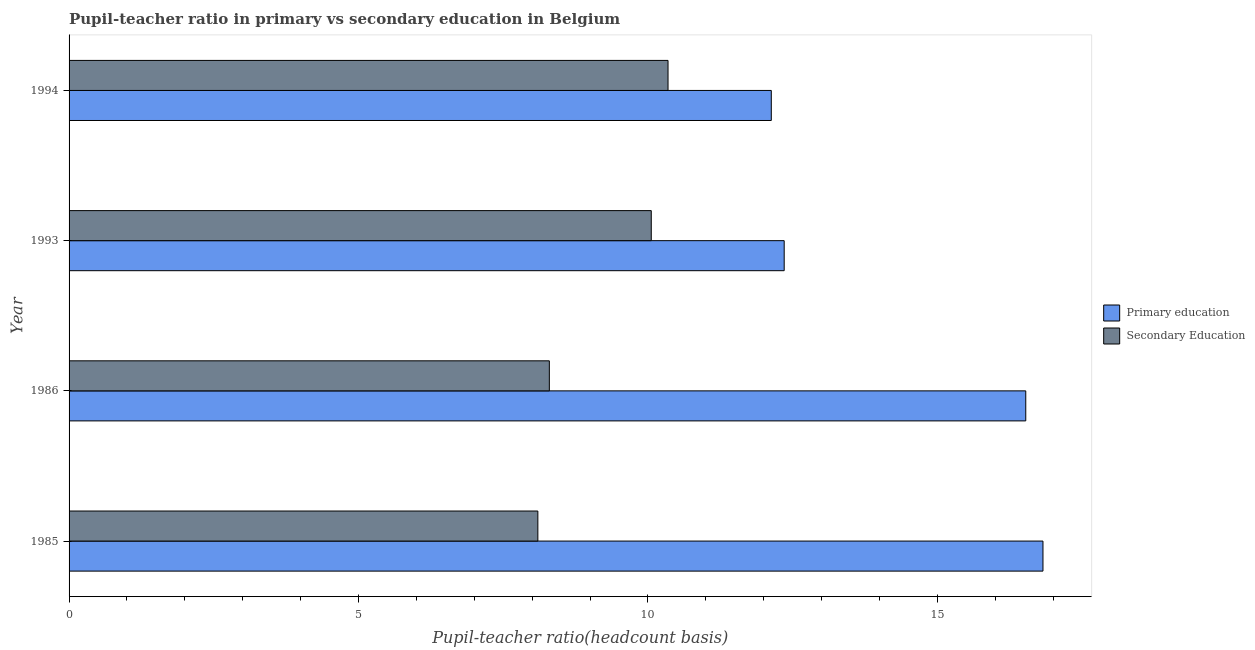How many different coloured bars are there?
Keep it short and to the point. 2. Are the number of bars on each tick of the Y-axis equal?
Your answer should be very brief. Yes. What is the label of the 4th group of bars from the top?
Provide a succinct answer. 1985. What is the pupil-teacher ratio in primary education in 1986?
Make the answer very short. 16.53. Across all years, what is the maximum pupil-teacher ratio in primary education?
Offer a terse response. 16.82. Across all years, what is the minimum pupil teacher ratio on secondary education?
Your answer should be compact. 8.1. What is the total pupil teacher ratio on secondary education in the graph?
Your answer should be very brief. 36.8. What is the difference between the pupil-teacher ratio in primary education in 1985 and that in 1993?
Offer a very short reply. 4.47. What is the difference between the pupil-teacher ratio in primary education in 1994 and the pupil teacher ratio on secondary education in 1986?
Offer a terse response. 3.83. What is the average pupil-teacher ratio in primary education per year?
Your answer should be very brief. 14.46. In the year 1994, what is the difference between the pupil-teacher ratio in primary education and pupil teacher ratio on secondary education?
Make the answer very short. 1.78. In how many years, is the pupil-teacher ratio in primary education greater than 9 ?
Keep it short and to the point. 4. What is the ratio of the pupil teacher ratio on secondary education in 1985 to that in 1993?
Keep it short and to the point. 0.81. Is the difference between the pupil-teacher ratio in primary education in 1986 and 1993 greater than the difference between the pupil teacher ratio on secondary education in 1986 and 1993?
Offer a very short reply. Yes. What is the difference between the highest and the second highest pupil teacher ratio on secondary education?
Your answer should be compact. 0.29. What is the difference between the highest and the lowest pupil-teacher ratio in primary education?
Offer a very short reply. 4.69. In how many years, is the pupil-teacher ratio in primary education greater than the average pupil-teacher ratio in primary education taken over all years?
Ensure brevity in your answer.  2. What does the 1st bar from the top in 1993 represents?
Ensure brevity in your answer.  Secondary Education. What does the 2nd bar from the bottom in 1986 represents?
Offer a terse response. Secondary Education. How many years are there in the graph?
Your answer should be compact. 4. What is the difference between two consecutive major ticks on the X-axis?
Give a very brief answer. 5. Where does the legend appear in the graph?
Provide a short and direct response. Center right. How many legend labels are there?
Keep it short and to the point. 2. How are the legend labels stacked?
Your answer should be very brief. Vertical. What is the title of the graph?
Your response must be concise. Pupil-teacher ratio in primary vs secondary education in Belgium. Does "Non-pregnant women" appear as one of the legend labels in the graph?
Ensure brevity in your answer.  No. What is the label or title of the X-axis?
Provide a short and direct response. Pupil-teacher ratio(headcount basis). What is the label or title of the Y-axis?
Provide a short and direct response. Year. What is the Pupil-teacher ratio(headcount basis) of Primary education in 1985?
Make the answer very short. 16.82. What is the Pupil-teacher ratio(headcount basis) of Secondary Education in 1985?
Make the answer very short. 8.1. What is the Pupil-teacher ratio(headcount basis) of Primary education in 1986?
Ensure brevity in your answer.  16.53. What is the Pupil-teacher ratio(headcount basis) of Secondary Education in 1986?
Provide a short and direct response. 8.3. What is the Pupil-teacher ratio(headcount basis) of Primary education in 1993?
Keep it short and to the point. 12.35. What is the Pupil-teacher ratio(headcount basis) of Secondary Education in 1993?
Your answer should be compact. 10.06. What is the Pupil-teacher ratio(headcount basis) in Primary education in 1994?
Make the answer very short. 12.13. What is the Pupil-teacher ratio(headcount basis) of Secondary Education in 1994?
Offer a very short reply. 10.35. Across all years, what is the maximum Pupil-teacher ratio(headcount basis) in Primary education?
Offer a very short reply. 16.82. Across all years, what is the maximum Pupil-teacher ratio(headcount basis) in Secondary Education?
Your answer should be very brief. 10.35. Across all years, what is the minimum Pupil-teacher ratio(headcount basis) of Primary education?
Provide a short and direct response. 12.13. Across all years, what is the minimum Pupil-teacher ratio(headcount basis) of Secondary Education?
Offer a very short reply. 8.1. What is the total Pupil-teacher ratio(headcount basis) in Primary education in the graph?
Your answer should be very brief. 57.83. What is the total Pupil-teacher ratio(headcount basis) of Secondary Education in the graph?
Your answer should be compact. 36.8. What is the difference between the Pupil-teacher ratio(headcount basis) in Primary education in 1985 and that in 1986?
Provide a succinct answer. 0.3. What is the difference between the Pupil-teacher ratio(headcount basis) of Secondary Education in 1985 and that in 1986?
Provide a succinct answer. -0.2. What is the difference between the Pupil-teacher ratio(headcount basis) of Primary education in 1985 and that in 1993?
Provide a succinct answer. 4.47. What is the difference between the Pupil-teacher ratio(headcount basis) in Secondary Education in 1985 and that in 1993?
Offer a very short reply. -1.96. What is the difference between the Pupil-teacher ratio(headcount basis) in Primary education in 1985 and that in 1994?
Make the answer very short. 4.69. What is the difference between the Pupil-teacher ratio(headcount basis) of Secondary Education in 1985 and that in 1994?
Make the answer very short. -2.25. What is the difference between the Pupil-teacher ratio(headcount basis) of Primary education in 1986 and that in 1993?
Make the answer very short. 4.17. What is the difference between the Pupil-teacher ratio(headcount basis) in Secondary Education in 1986 and that in 1993?
Make the answer very short. -1.76. What is the difference between the Pupil-teacher ratio(headcount basis) in Primary education in 1986 and that in 1994?
Make the answer very short. 4.4. What is the difference between the Pupil-teacher ratio(headcount basis) of Secondary Education in 1986 and that in 1994?
Keep it short and to the point. -2.05. What is the difference between the Pupil-teacher ratio(headcount basis) of Primary education in 1993 and that in 1994?
Offer a terse response. 0.22. What is the difference between the Pupil-teacher ratio(headcount basis) of Secondary Education in 1993 and that in 1994?
Keep it short and to the point. -0.29. What is the difference between the Pupil-teacher ratio(headcount basis) of Primary education in 1985 and the Pupil-teacher ratio(headcount basis) of Secondary Education in 1986?
Your response must be concise. 8.53. What is the difference between the Pupil-teacher ratio(headcount basis) of Primary education in 1985 and the Pupil-teacher ratio(headcount basis) of Secondary Education in 1993?
Keep it short and to the point. 6.77. What is the difference between the Pupil-teacher ratio(headcount basis) of Primary education in 1985 and the Pupil-teacher ratio(headcount basis) of Secondary Education in 1994?
Your response must be concise. 6.48. What is the difference between the Pupil-teacher ratio(headcount basis) of Primary education in 1986 and the Pupil-teacher ratio(headcount basis) of Secondary Education in 1993?
Provide a short and direct response. 6.47. What is the difference between the Pupil-teacher ratio(headcount basis) of Primary education in 1986 and the Pupil-teacher ratio(headcount basis) of Secondary Education in 1994?
Offer a very short reply. 6.18. What is the difference between the Pupil-teacher ratio(headcount basis) of Primary education in 1993 and the Pupil-teacher ratio(headcount basis) of Secondary Education in 1994?
Your answer should be very brief. 2.01. What is the average Pupil-teacher ratio(headcount basis) of Primary education per year?
Your answer should be very brief. 14.46. What is the average Pupil-teacher ratio(headcount basis) of Secondary Education per year?
Keep it short and to the point. 9.2. In the year 1985, what is the difference between the Pupil-teacher ratio(headcount basis) in Primary education and Pupil-teacher ratio(headcount basis) in Secondary Education?
Ensure brevity in your answer.  8.73. In the year 1986, what is the difference between the Pupil-teacher ratio(headcount basis) of Primary education and Pupil-teacher ratio(headcount basis) of Secondary Education?
Make the answer very short. 8.23. In the year 1993, what is the difference between the Pupil-teacher ratio(headcount basis) of Primary education and Pupil-teacher ratio(headcount basis) of Secondary Education?
Make the answer very short. 2.3. In the year 1994, what is the difference between the Pupil-teacher ratio(headcount basis) in Primary education and Pupil-teacher ratio(headcount basis) in Secondary Education?
Your answer should be very brief. 1.78. What is the ratio of the Pupil-teacher ratio(headcount basis) of Secondary Education in 1985 to that in 1986?
Your response must be concise. 0.98. What is the ratio of the Pupil-teacher ratio(headcount basis) of Primary education in 1985 to that in 1993?
Your response must be concise. 1.36. What is the ratio of the Pupil-teacher ratio(headcount basis) of Secondary Education in 1985 to that in 1993?
Keep it short and to the point. 0.81. What is the ratio of the Pupil-teacher ratio(headcount basis) in Primary education in 1985 to that in 1994?
Offer a terse response. 1.39. What is the ratio of the Pupil-teacher ratio(headcount basis) of Secondary Education in 1985 to that in 1994?
Ensure brevity in your answer.  0.78. What is the ratio of the Pupil-teacher ratio(headcount basis) of Primary education in 1986 to that in 1993?
Your answer should be compact. 1.34. What is the ratio of the Pupil-teacher ratio(headcount basis) in Secondary Education in 1986 to that in 1993?
Provide a succinct answer. 0.82. What is the ratio of the Pupil-teacher ratio(headcount basis) in Primary education in 1986 to that in 1994?
Give a very brief answer. 1.36. What is the ratio of the Pupil-teacher ratio(headcount basis) of Secondary Education in 1986 to that in 1994?
Offer a very short reply. 0.8. What is the ratio of the Pupil-teacher ratio(headcount basis) of Primary education in 1993 to that in 1994?
Your answer should be very brief. 1.02. What is the ratio of the Pupil-teacher ratio(headcount basis) in Secondary Education in 1993 to that in 1994?
Ensure brevity in your answer.  0.97. What is the difference between the highest and the second highest Pupil-teacher ratio(headcount basis) in Primary education?
Offer a terse response. 0.3. What is the difference between the highest and the second highest Pupil-teacher ratio(headcount basis) of Secondary Education?
Offer a terse response. 0.29. What is the difference between the highest and the lowest Pupil-teacher ratio(headcount basis) of Primary education?
Your answer should be compact. 4.69. What is the difference between the highest and the lowest Pupil-teacher ratio(headcount basis) of Secondary Education?
Offer a terse response. 2.25. 